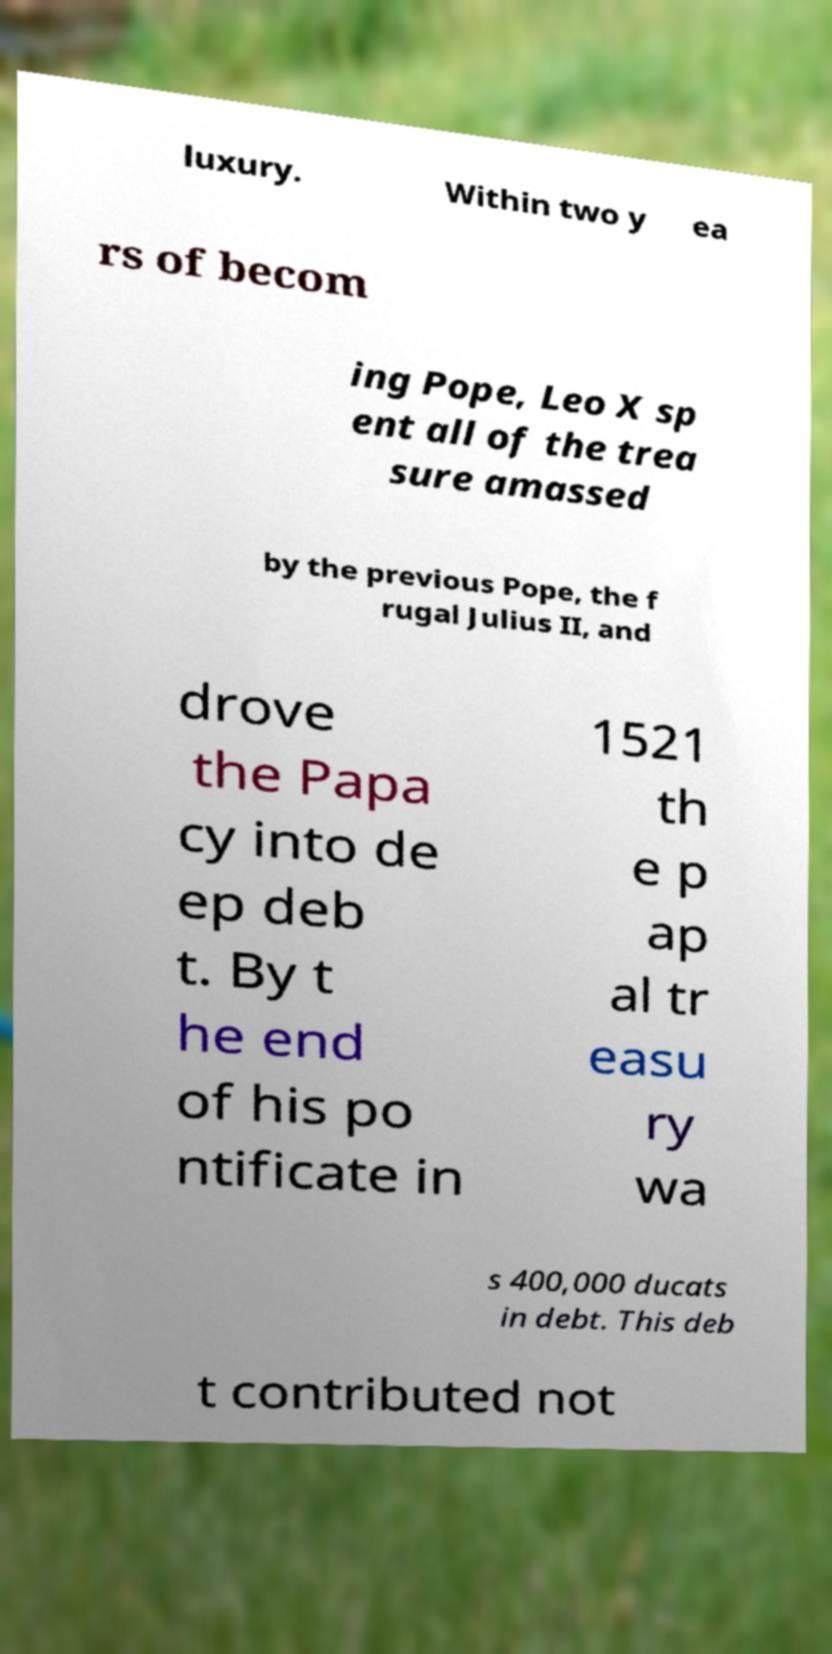Please read and relay the text visible in this image. What does it say? luxury. Within two y ea rs of becom ing Pope, Leo X sp ent all of the trea sure amassed by the previous Pope, the f rugal Julius II, and drove the Papa cy into de ep deb t. By t he end of his po ntificate in 1521 th e p ap al tr easu ry wa s 400,000 ducats in debt. This deb t contributed not 